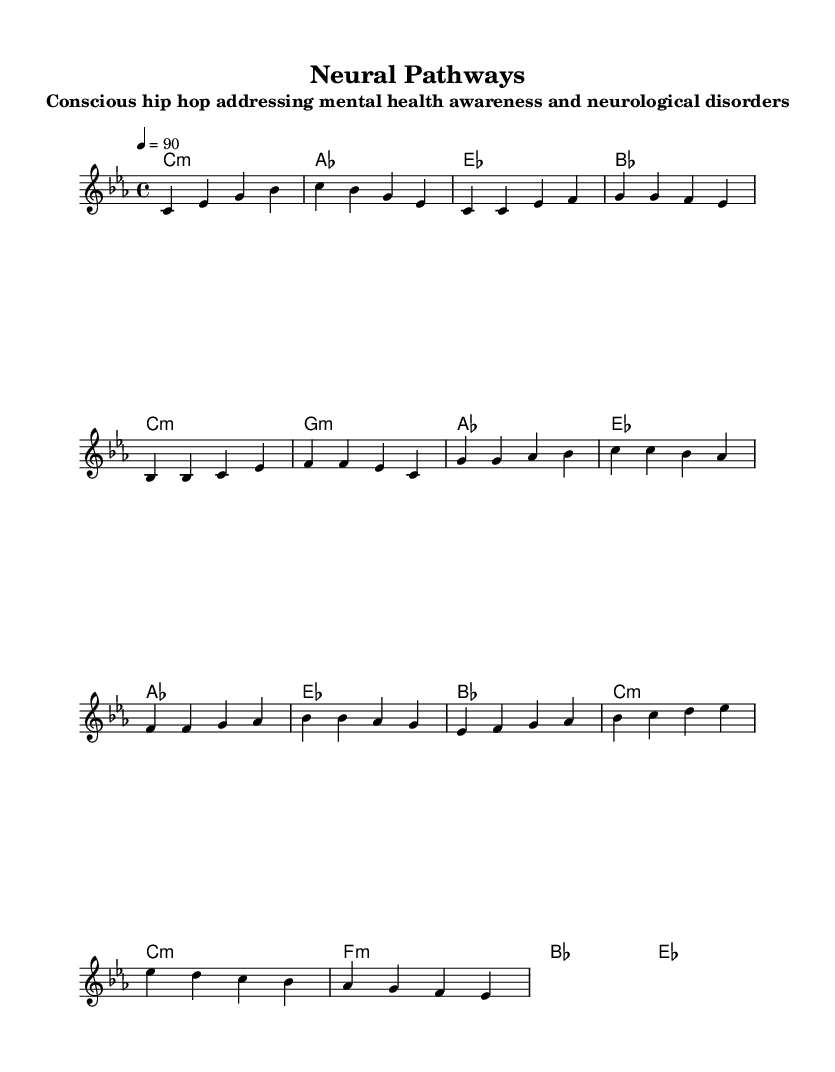What is the key signature of this music? The key signature is C minor, which has three flats (B♭, E♭, A♭). The presence of these flats indicates the minor tonal context.
Answer: C minor What is the time signature of this music? The time signature is 4/4, meaning there are four beats in each measure and the quarter note receives one beat. This is indicated at the beginning of the sheet music.
Answer: 4/4 What is the tempo marking for this piece? The tempo marking is 90 beats per minute, indicating a moderate speed. It is clearly noted in the tempo indication at the start of the song.
Answer: 90 How many sections does the music have? The music consists of four sections: Intro, Verse, Chorus, and Bridge. Each section is defined by distinct musical phrases reflected in the melody and harmonies.
Answer: Four What is the primary theme addressed in this piece? The primary theme of the piece addresses mental health awareness and neurological disorders, as stated in the subtitle. The choice of lyrical content and the structure reflects deeper social consciousness prevalent in conscious hip hop.
Answer: Mental health awareness Which chord is used in the chorus? The chord used in the chorus is B♭ major, which is part of the harmonic progression noted during the chorus section. This is seen in the chord changes that accompany the melody.
Answer: B♭ What style of hip hop does this piece represent? This piece represents conscious hip hop, which focuses on social issues such as mental health. The musical and lyrical elements promote awareness and understanding of neurological disorders.
Answer: Conscious hip hop 